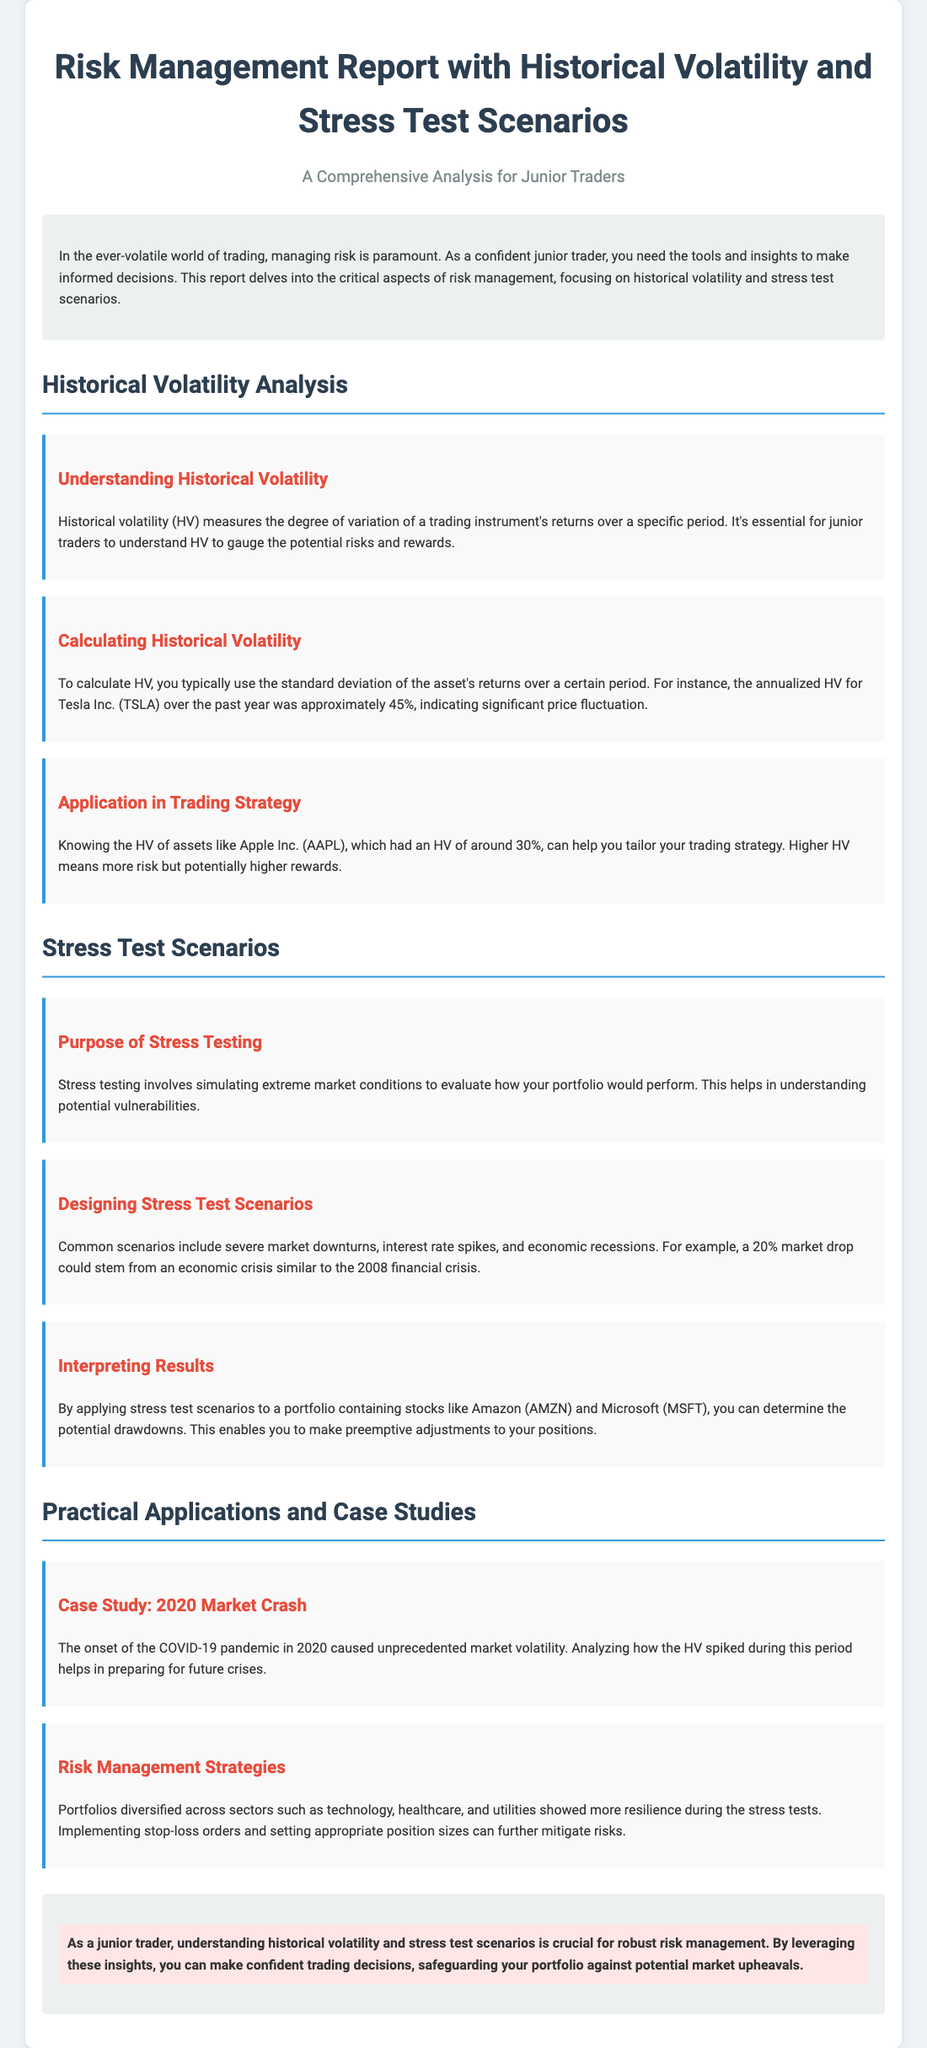what is the title of the report? The title of the report is prominently displayed at the top of the document.
Answer: Risk Management Report with Historical Volatility and Stress Test Scenarios what is the annualized historical volatility for Tesla Inc.? The document provides an example of Tesla's historical volatility, indicating the percentage.
Answer: 45% which stock had an HV of around 30%? This question pertains to a specific asset discussed in the document.
Answer: Apple Inc what are two common scenarios used in stress testing? The document mentions types of scenarios that can be designed for stress testing.
Answer: Severe market downturns, interest rate spikes what event triggered unprecedented market volatility in 2020? This question refers to a key event mentioned in the case study of the document.
Answer: COVID-19 pandemic what does the highlight in the conclusion emphasize? The highlight summarizes the importance of two concepts discussed throughout the report.
Answer: Understanding historical volatility and stress test scenarios what is essential for robust risk management according to the conclusion? The conclusion states what is crucial for a junior trader regarding risk management.
Answer: Understanding historical volatility and stress test scenarios 